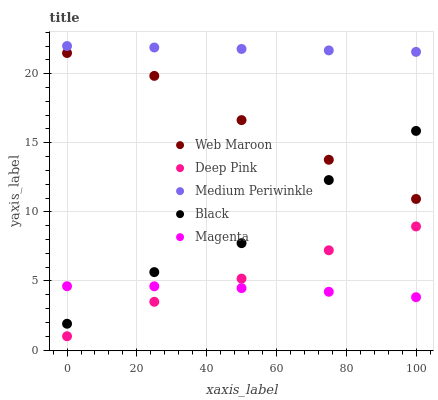Does Magenta have the minimum area under the curve?
Answer yes or no. Yes. Does Medium Periwinkle have the maximum area under the curve?
Answer yes or no. Yes. Does Deep Pink have the minimum area under the curve?
Answer yes or no. No. Does Deep Pink have the maximum area under the curve?
Answer yes or no. No. Is Medium Periwinkle the smoothest?
Answer yes or no. Yes. Is Black the roughest?
Answer yes or no. Yes. Is Magenta the smoothest?
Answer yes or no. No. Is Magenta the roughest?
Answer yes or no. No. Does Deep Pink have the lowest value?
Answer yes or no. Yes. Does Magenta have the lowest value?
Answer yes or no. No. Does Medium Periwinkle have the highest value?
Answer yes or no. Yes. Does Deep Pink have the highest value?
Answer yes or no. No. Is Magenta less than Web Maroon?
Answer yes or no. Yes. Is Medium Periwinkle greater than Deep Pink?
Answer yes or no. Yes. Does Magenta intersect Black?
Answer yes or no. Yes. Is Magenta less than Black?
Answer yes or no. No. Is Magenta greater than Black?
Answer yes or no. No. Does Magenta intersect Web Maroon?
Answer yes or no. No. 